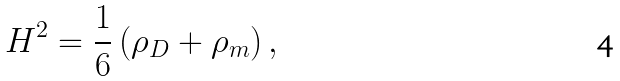<formula> <loc_0><loc_0><loc_500><loc_500>H ^ { 2 } = \frac { 1 } { 6 } \left ( \rho _ { D } + \rho _ { m } \right ) ,</formula> 